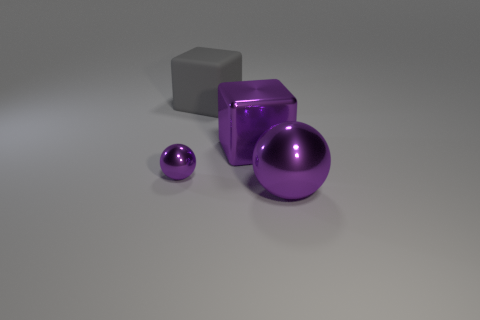Add 1 small cyan cubes. How many objects exist? 5 Subtract all yellow cubes. How many red spheres are left? 0 Subtract all gray rubber things. Subtract all large purple blocks. How many objects are left? 2 Add 4 metal objects. How many metal objects are left? 7 Add 1 big shiny objects. How many big shiny objects exist? 3 Subtract all purple blocks. How many blocks are left? 1 Subtract 0 green cubes. How many objects are left? 4 Subtract all purple blocks. Subtract all blue spheres. How many blocks are left? 1 